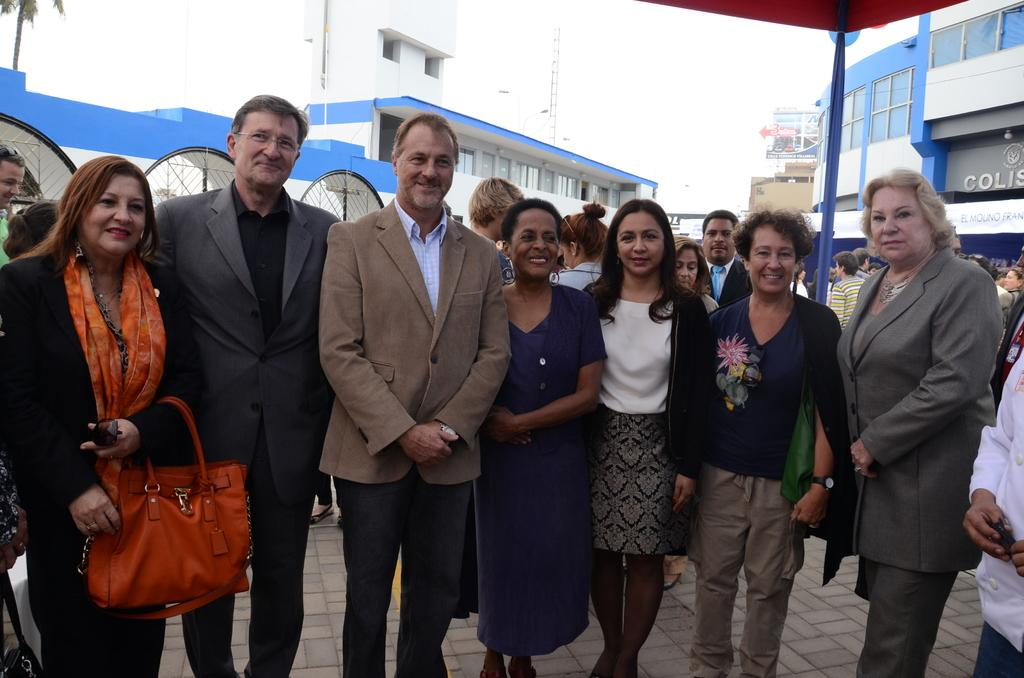What type of structures can be seen in the image? There are buildings in the image. Are there any people present in the image? Yes, there are people standing in the image. What is the woman holding in her hand? The woman is holding a bag in her hand. What type of vegetation is visible in the image? There is a tree visible in the image. What type of doctor can be seen attending to the aftermath of the incident in the image? There is no doctor or incident present in the image; it features buildings, people, and a woman holding a bag. What type of rest can be seen in the image? There is no rest or resting area visible in the image. 